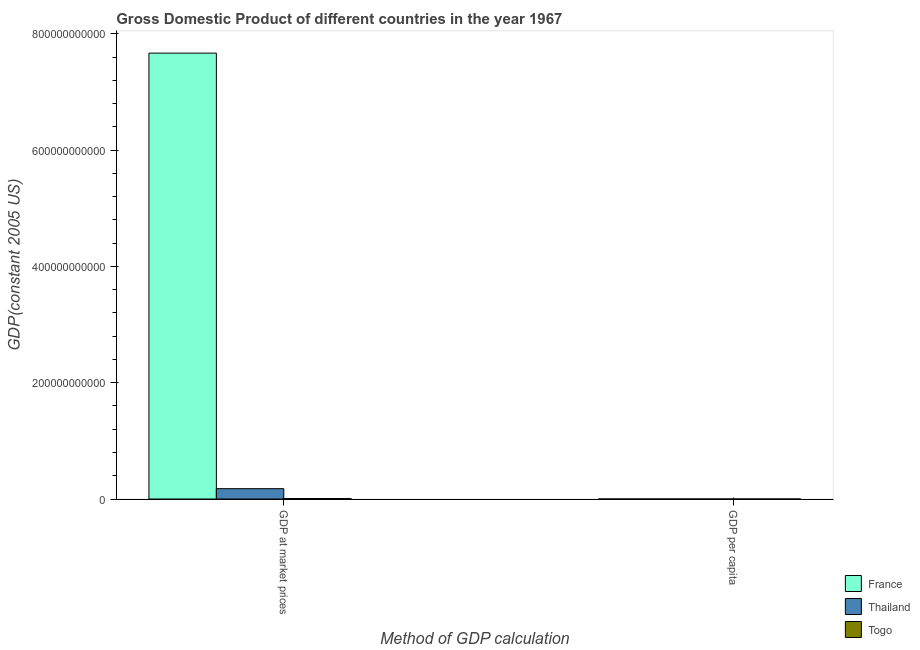How many different coloured bars are there?
Your answer should be compact. 3. How many groups of bars are there?
Provide a succinct answer. 2. How many bars are there on the 1st tick from the left?
Make the answer very short. 3. What is the label of the 1st group of bars from the left?
Offer a terse response. GDP at market prices. What is the gdp at market prices in Togo?
Your answer should be compact. 8.02e+08. Across all countries, what is the maximum gdp at market prices?
Offer a terse response. 7.67e+11. Across all countries, what is the minimum gdp per capita?
Your answer should be very brief. 432.16. In which country was the gdp at market prices maximum?
Keep it short and to the point. France. In which country was the gdp at market prices minimum?
Give a very brief answer. Togo. What is the total gdp at market prices in the graph?
Offer a very short reply. 7.86e+11. What is the difference between the gdp at market prices in Togo and that in Thailand?
Provide a short and direct response. -1.70e+1. What is the difference between the gdp per capita in Thailand and the gdp at market prices in Togo?
Make the answer very short. -8.02e+08. What is the average gdp at market prices per country?
Give a very brief answer. 2.62e+11. What is the difference between the gdp per capita and gdp at market prices in Thailand?
Offer a very short reply. -1.78e+1. In how many countries, is the gdp at market prices greater than 520000000000 US$?
Keep it short and to the point. 1. What is the ratio of the gdp per capita in France to that in Thailand?
Provide a succinct answer. 28.56. In how many countries, is the gdp at market prices greater than the average gdp at market prices taken over all countries?
Your answer should be very brief. 1. What does the 2nd bar from the left in GDP per capita represents?
Your response must be concise. Thailand. What does the 1st bar from the right in GDP per capita represents?
Make the answer very short. Togo. How many bars are there?
Provide a short and direct response. 6. Are all the bars in the graph horizontal?
Keep it short and to the point. No. How many countries are there in the graph?
Provide a short and direct response. 3. What is the difference between two consecutive major ticks on the Y-axis?
Your answer should be compact. 2.00e+11. Are the values on the major ticks of Y-axis written in scientific E-notation?
Keep it short and to the point. No. Does the graph contain any zero values?
Provide a succinct answer. No. How many legend labels are there?
Your response must be concise. 3. What is the title of the graph?
Your answer should be compact. Gross Domestic Product of different countries in the year 1967. Does "Antigua and Barbuda" appear as one of the legend labels in the graph?
Keep it short and to the point. No. What is the label or title of the X-axis?
Offer a very short reply. Method of GDP calculation. What is the label or title of the Y-axis?
Make the answer very short. GDP(constant 2005 US). What is the GDP(constant 2005 US) in France in GDP at market prices?
Make the answer very short. 7.67e+11. What is the GDP(constant 2005 US) of Thailand in GDP at market prices?
Your answer should be compact. 1.78e+1. What is the GDP(constant 2005 US) of Togo in GDP at market prices?
Your response must be concise. 8.02e+08. What is the GDP(constant 2005 US) in France in GDP per capita?
Offer a terse response. 1.51e+04. What is the GDP(constant 2005 US) in Thailand in GDP per capita?
Your response must be concise. 527.36. What is the GDP(constant 2005 US) in Togo in GDP per capita?
Offer a very short reply. 432.16. Across all Method of GDP calculation, what is the maximum GDP(constant 2005 US) in France?
Keep it short and to the point. 7.67e+11. Across all Method of GDP calculation, what is the maximum GDP(constant 2005 US) in Thailand?
Offer a very short reply. 1.78e+1. Across all Method of GDP calculation, what is the maximum GDP(constant 2005 US) in Togo?
Offer a terse response. 8.02e+08. Across all Method of GDP calculation, what is the minimum GDP(constant 2005 US) in France?
Offer a very short reply. 1.51e+04. Across all Method of GDP calculation, what is the minimum GDP(constant 2005 US) in Thailand?
Your response must be concise. 527.36. Across all Method of GDP calculation, what is the minimum GDP(constant 2005 US) in Togo?
Ensure brevity in your answer.  432.16. What is the total GDP(constant 2005 US) in France in the graph?
Offer a terse response. 7.67e+11. What is the total GDP(constant 2005 US) of Thailand in the graph?
Make the answer very short. 1.78e+1. What is the total GDP(constant 2005 US) of Togo in the graph?
Offer a terse response. 8.02e+08. What is the difference between the GDP(constant 2005 US) of France in GDP at market prices and that in GDP per capita?
Your answer should be very brief. 7.67e+11. What is the difference between the GDP(constant 2005 US) in Thailand in GDP at market prices and that in GDP per capita?
Your answer should be very brief. 1.78e+1. What is the difference between the GDP(constant 2005 US) in Togo in GDP at market prices and that in GDP per capita?
Your response must be concise. 8.02e+08. What is the difference between the GDP(constant 2005 US) in France in GDP at market prices and the GDP(constant 2005 US) in Thailand in GDP per capita?
Your response must be concise. 7.67e+11. What is the difference between the GDP(constant 2005 US) of France in GDP at market prices and the GDP(constant 2005 US) of Togo in GDP per capita?
Provide a short and direct response. 7.67e+11. What is the difference between the GDP(constant 2005 US) of Thailand in GDP at market prices and the GDP(constant 2005 US) of Togo in GDP per capita?
Your response must be concise. 1.78e+1. What is the average GDP(constant 2005 US) of France per Method of GDP calculation?
Your answer should be compact. 3.83e+11. What is the average GDP(constant 2005 US) of Thailand per Method of GDP calculation?
Your answer should be compact. 8.91e+09. What is the average GDP(constant 2005 US) of Togo per Method of GDP calculation?
Offer a terse response. 4.01e+08. What is the difference between the GDP(constant 2005 US) of France and GDP(constant 2005 US) of Thailand in GDP at market prices?
Make the answer very short. 7.49e+11. What is the difference between the GDP(constant 2005 US) in France and GDP(constant 2005 US) in Togo in GDP at market prices?
Keep it short and to the point. 7.66e+11. What is the difference between the GDP(constant 2005 US) of Thailand and GDP(constant 2005 US) of Togo in GDP at market prices?
Make the answer very short. 1.70e+1. What is the difference between the GDP(constant 2005 US) in France and GDP(constant 2005 US) in Thailand in GDP per capita?
Provide a succinct answer. 1.45e+04. What is the difference between the GDP(constant 2005 US) of France and GDP(constant 2005 US) of Togo in GDP per capita?
Offer a terse response. 1.46e+04. What is the difference between the GDP(constant 2005 US) in Thailand and GDP(constant 2005 US) in Togo in GDP per capita?
Provide a succinct answer. 95.2. What is the ratio of the GDP(constant 2005 US) in France in GDP at market prices to that in GDP per capita?
Offer a terse response. 5.09e+07. What is the ratio of the GDP(constant 2005 US) of Thailand in GDP at market prices to that in GDP per capita?
Provide a short and direct response. 3.38e+07. What is the ratio of the GDP(constant 2005 US) in Togo in GDP at market prices to that in GDP per capita?
Provide a succinct answer. 1.86e+06. What is the difference between the highest and the second highest GDP(constant 2005 US) in France?
Provide a short and direct response. 7.67e+11. What is the difference between the highest and the second highest GDP(constant 2005 US) in Thailand?
Your answer should be very brief. 1.78e+1. What is the difference between the highest and the second highest GDP(constant 2005 US) of Togo?
Offer a terse response. 8.02e+08. What is the difference between the highest and the lowest GDP(constant 2005 US) of France?
Offer a very short reply. 7.67e+11. What is the difference between the highest and the lowest GDP(constant 2005 US) in Thailand?
Your response must be concise. 1.78e+1. What is the difference between the highest and the lowest GDP(constant 2005 US) of Togo?
Keep it short and to the point. 8.02e+08. 